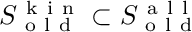Convert formula to latex. <formula><loc_0><loc_0><loc_500><loc_500>S _ { o l d } ^ { k i n } \subset S _ { o l d } ^ { a l l }</formula> 